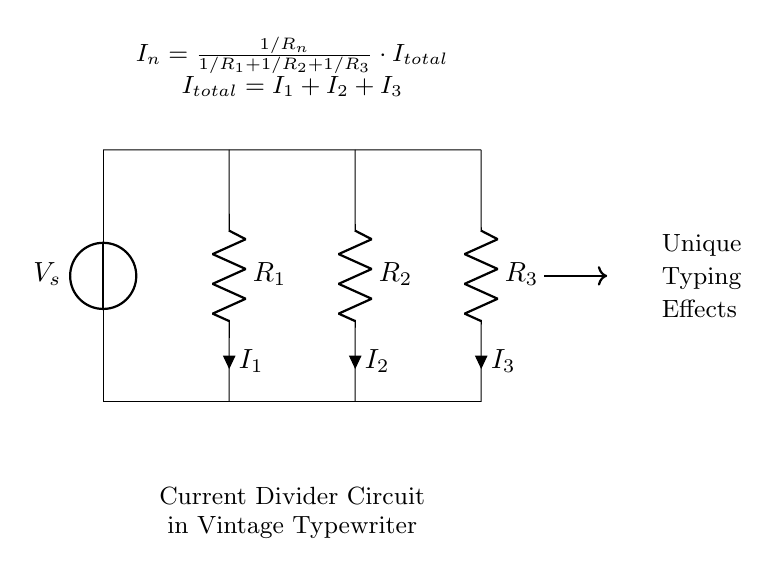What components are in this circuit? The components described in the circuit include a voltage source \(V_s\) and three resistors \(R_1\), \(R_2\), and \(R_3\). These components are connected in parallel with respect to \(V_s\).
Answer: Voltage source and resistors What is the total current in the circuit? The total current \(I_{total}\) is the sum of the individual currents through each resistor, represented by the equation \(I_{total} = I_1 + I_2 + I_3\).
Answer: \(I_{total}\) How does the current divide among the resistors? The current through each resistor is given by the formula \(I_n = \frac{1/R_n}{1/R_1 + 1/R_2 + 1/R_3} \cdot I_{total}\), indicating that the current divides inversely with resistance.
Answer: Inversely with resistance What are the relationships between the resistors in this circuit? The resistors are connected in parallel, which affects how voltage and current distribute across them; specifically, they share the same voltage \(V_s\) while the total current varies inversely relative to their resistances.
Answer: Parallel connection What would happen if one of the resistors is removed from the circuit? If one of the resistors is removed, the total resistance of the circuit would decrease, leading to an increase in \(I_{total}\) according to Ohm's Law, thus changing the current through the remaining resistors.
Answer: Increase in total current Which component has the highest current flowing through it? The component with the highest current will be the one with the lowest resistance, based on the current divider principle; without specific resistance values, we cannot definitively identify it, but it will be one of the resistors.
Answer: Lowest resistance 